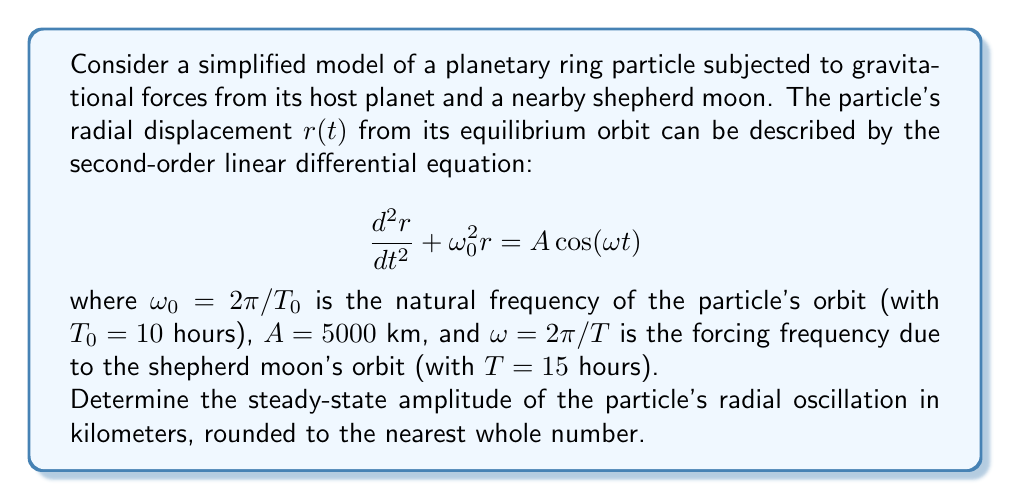What is the answer to this math problem? To solve this problem, we'll follow these steps:

1) First, recall the general solution for a forced oscillation:

   $$ r(t) = R \cos(\omega t - \phi) $$

   where $R$ is the amplitude we're looking for.

2) The amplitude $R$ for a forced oscillation is given by:

   $$ R = \frac{A}{\sqrt{(\omega_0^2 - \omega^2)^2}} $$

3) Calculate $\omega_0$:
   $$ \omega_0 = \frac{2\pi}{T_0} = \frac{2\pi}{10} = 0.6283 \text{ rad/hr} $$

4) Calculate $\omega$:
   $$ \omega = \frac{2\pi}{T} = \frac{2\pi}{15} = 0.4189 \text{ rad/hr} $$

5) Now, let's substitute these values into our amplitude equation:

   $$ R = \frac{5000}{\sqrt{(0.6283^2 - 0.4189^2)^2}} $$

6) Simplify:
   $$ R = \frac{5000}{\sqrt{(0.3948 - 0.1755)^2}} = \frac{5000}{\sqrt{0.0482^2}} = \frac{5000}{0.0482} $$

7) Calculate the final result:
   $$ R = 103734.44 \text{ km} $$

8) Rounding to the nearest whole number:
   $$ R \approx 103734 \text{ km} $$
Answer: 103734 km 